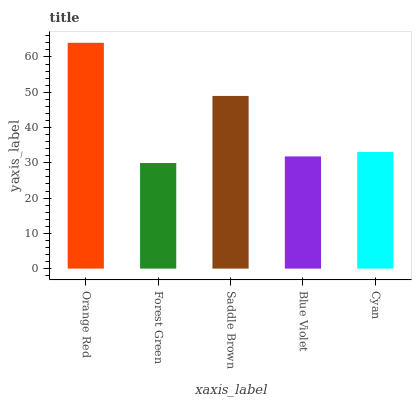Is Forest Green the minimum?
Answer yes or no. Yes. Is Orange Red the maximum?
Answer yes or no. Yes. Is Saddle Brown the minimum?
Answer yes or no. No. Is Saddle Brown the maximum?
Answer yes or no. No. Is Saddle Brown greater than Forest Green?
Answer yes or no. Yes. Is Forest Green less than Saddle Brown?
Answer yes or no. Yes. Is Forest Green greater than Saddle Brown?
Answer yes or no. No. Is Saddle Brown less than Forest Green?
Answer yes or no. No. Is Cyan the high median?
Answer yes or no. Yes. Is Cyan the low median?
Answer yes or no. Yes. Is Forest Green the high median?
Answer yes or no. No. Is Forest Green the low median?
Answer yes or no. No. 